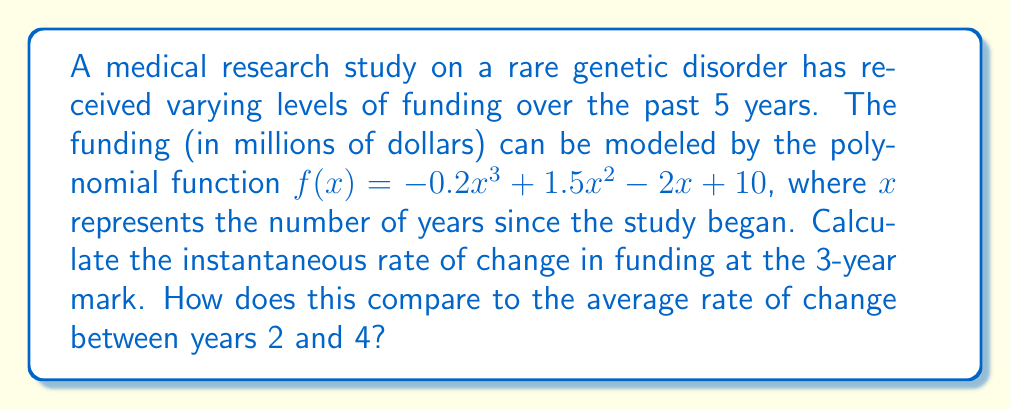Can you answer this question? To solve this problem, we need to follow these steps:

1. Find the instantaneous rate of change at x = 3:
   The instantaneous rate of change is given by the derivative of the function at x = 3.
   
   $$f'(x) = -0.6x^2 + 3x - 2$$
   $$f'(3) = -0.6(3)^2 + 3(3) - 2 = -5.4 + 9 - 2 = 1.6$$

2. Find the average rate of change between x = 2 and x = 4:
   The average rate of change is calculated using the formula:
   $$\text{Average rate of change} = \frac{f(4) - f(2)}{4 - 2}$$

   First, calculate f(2) and f(4):
   $$f(2) = -0.2(2)^3 + 1.5(2)^2 - 2(2) + 10 = -1.6 + 6 - 4 + 10 = 10.4$$
   $$f(4) = -0.2(4)^3 + 1.5(4)^2 - 2(4) + 10 = -12.8 + 24 - 8 + 10 = 13.2$$

   Now, apply the formula:
   $$\text{Average rate of change} = \frac{13.2 - 10.4}{4 - 2} = \frac{2.8}{2} = 1.4$$

3. Compare the instantaneous rate of change at x = 3 (1.6) to the average rate of change between x = 2 and x = 4 (1.4):
   The instantaneous rate of change (1.6) is slightly higher than the average rate of change (1.4), indicating that the funding was increasing slightly faster at the 3-year mark compared to the average increase over the 2-year period.
Answer: The instantaneous rate of change at the 3-year mark is 1.6 million dollars per year. The average rate of change between years 2 and 4 is 1.4 million dollars per year. The instantaneous rate of change is 0.2 million dollars per year higher than the average rate of change. 